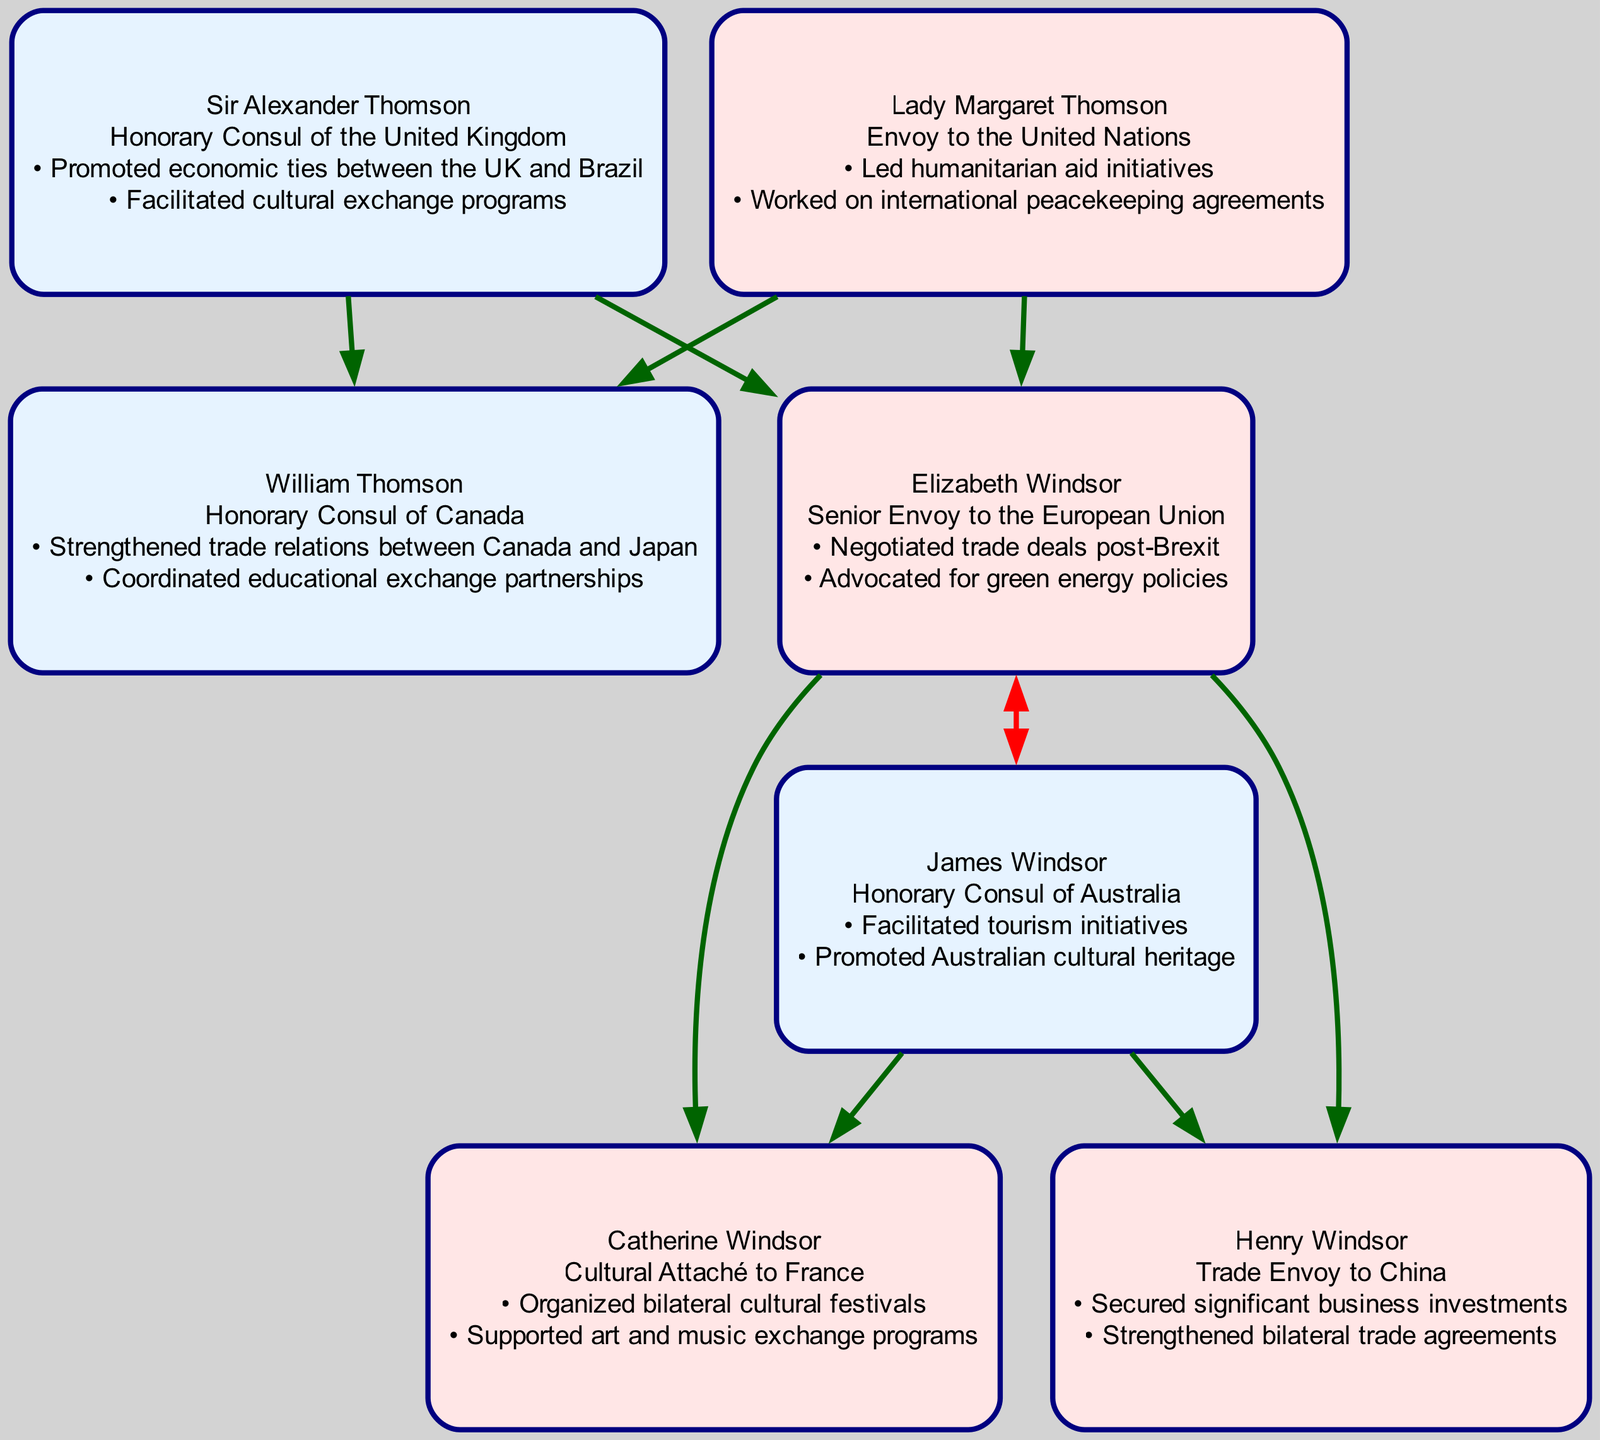What is the role of Sir Alexander Thomson? According to the diagram, Sir Alexander Thomson is labeled as the "Honorary Consul of the United Kingdom."
Answer: Honorary Consul of the United Kingdom How many children do Sir Alexander Thomson and Lady Margaret Thomson have? By looking at the connections in the diagram, Sir Alexander Thomson and Lady Margaret Thomson have two children; William Thomson and Elizabeth Windsor.
Answer: 2 What contributions did Elizabeth Windsor make to diplomatic relations? The diagram states that Elizabeth Windsor negotiated trade deals post-Brexit and advocated for green energy policies.
Answer: Negotiated trade deals post-Brexit; Advocated for green energy policies Which family member is the husband of Elizabeth Windsor? The diagram clearly identifies James Windsor as the husband of Elizabeth Windsor.
Answer: James Windsor What is the relationship between Henry Windsor and Sir Alexander Thomson? Tracing back through the diagram, Henry Windsor is the grandson of Sir Alexander Thomson, as he is the son of Elizabeth Windsor, who is Sir Alexander’s daughter.
Answer: Grandson Who is the Cultural Attaché to France according to the family tree? The diagram indicates that Catherine Windsor serves as the Cultural Attaché to France.
Answer: Catherine Windsor List one of the contributions made by Lady Margaret Thomson. The diagram highlights that Lady Margaret Thomson led humanitarian aid initiatives and worked on international peacekeeping agreements.
Answer: Led humanitarian aid initiatives What role does William Thomson hold? The diagram specifies that William Thomson is the "Honorary Consul of Canada."
Answer: Honorary Consul of Canada What type of envoy is James Windsor? From the diagram, James Windsor is identified as the "Honorary Consul of Australia."
Answer: Honorary Consul of Australia 